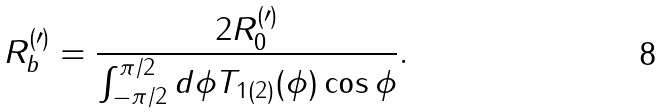Convert formula to latex. <formula><loc_0><loc_0><loc_500><loc_500>R _ { b } ^ { ( \prime ) } = \frac { 2 R _ { 0 } ^ { ( \prime ) } } { \int _ { - \pi / 2 } ^ { \pi / 2 } d \phi T _ { 1 ( 2 ) } ( \phi ) \cos \phi } .</formula> 